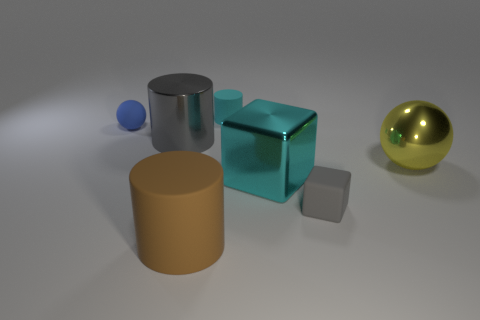What shape is the big yellow thing?
Provide a short and direct response. Sphere. What size is the blue thing that is the same shape as the yellow metal object?
Your answer should be compact. Small. Are there any other things that are the same material as the big cyan block?
Your response must be concise. Yes. There is a cylinder that is on the right side of the big brown matte object that is on the right side of the tiny rubber sphere; what size is it?
Your answer should be very brief. Small. Are there the same number of small blue rubber spheres on the right side of the small cyan cylinder and tiny cylinders?
Offer a very short reply. No. How many other things are the same color as the small sphere?
Your answer should be very brief. 0. Are there fewer yellow metal objects behind the tiny rubber ball than large metal cubes?
Offer a terse response. Yes. Is there a gray cube of the same size as the metal cylinder?
Offer a terse response. No. Does the large metal ball have the same color as the small object left of the small cyan cylinder?
Offer a very short reply. No. How many balls are on the right side of the thing on the right side of the tiny gray object?
Keep it short and to the point. 0. 